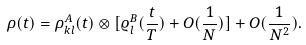Convert formula to latex. <formula><loc_0><loc_0><loc_500><loc_500>\rho ( t ) = \rho _ { k l } ^ { A } ( t ) \otimes [ \varrho ^ { B } _ { l } ( \frac { t } { T } ) + O ( \frac { 1 } { N } ) ] + O ( \frac { 1 } { N ^ { 2 } } ) .</formula> 